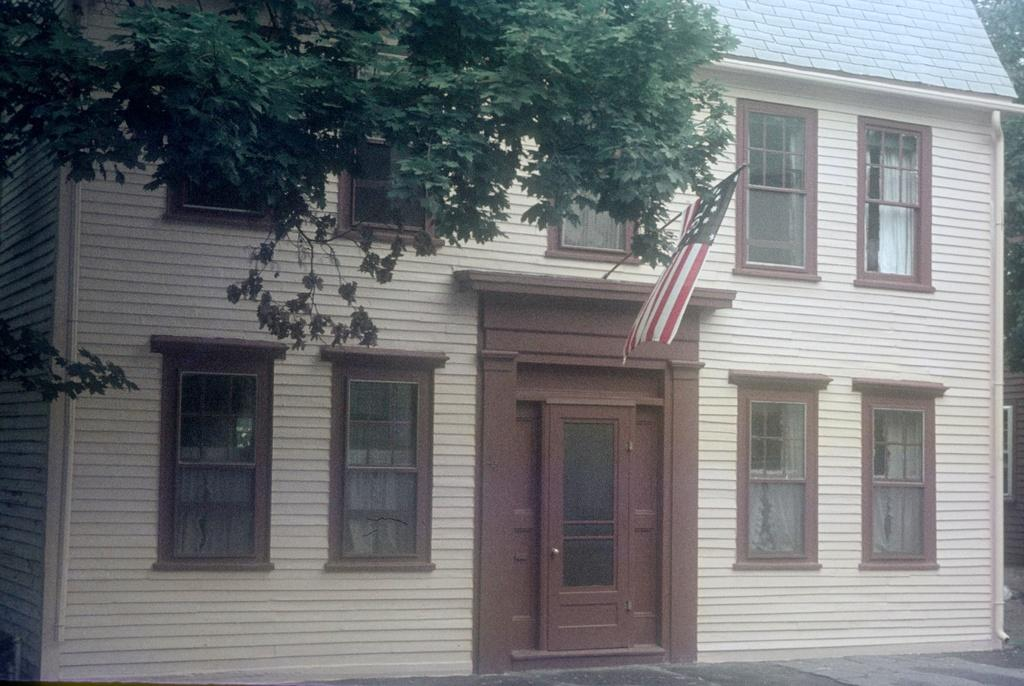What type of building is in the picture? There is a house in the picture. What features can be seen on the house? The house has windows and a door. What additional object is present in the picture? There is a flag in the picture. What type of natural elements can be seen in the picture? There are trees in the picture. Can you tell me how many brothers are standing next to the stranger in the picture? There is no mention of brothers or a stranger in the picture; it only features a house, windows, a door, a flag, and trees. 